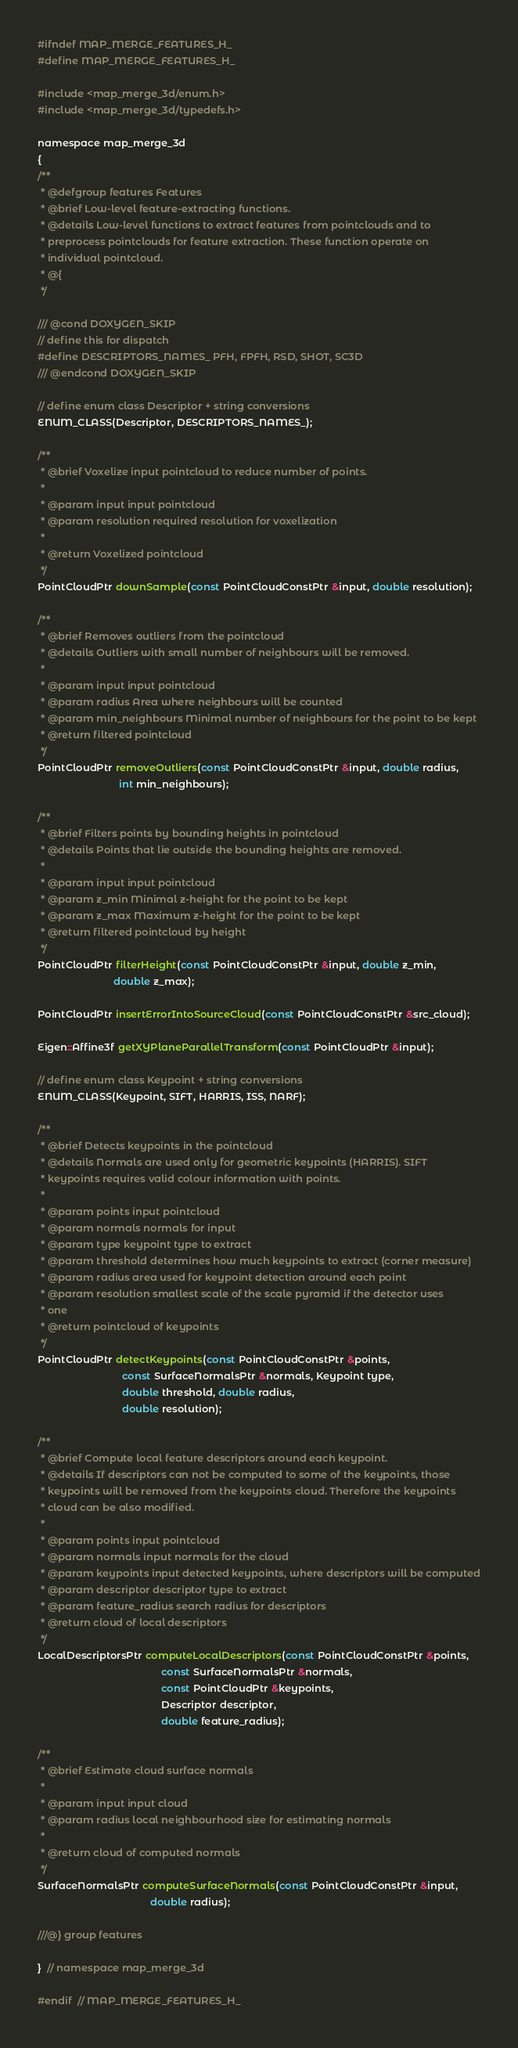<code> <loc_0><loc_0><loc_500><loc_500><_C_>#ifndef MAP_MERGE_FEATURES_H_
#define MAP_MERGE_FEATURES_H_

#include <map_merge_3d/enum.h>
#include <map_merge_3d/typedefs.h>

namespace map_merge_3d
{
/**
 * @defgroup features Features
 * @brief Low-level feature-extracting functions.
 * @details Low-level functions to extract features from pointclouds and to
 * preprocess pointclouds for feature extraction. These function operate on
 * individual pointcloud.
 * @{
 */

/// @cond DOXYGEN_SKIP
// define this for dispatch
#define DESCRIPTORS_NAMES_ PFH, FPFH, RSD, SHOT, SC3D
/// @endcond DOXYGEN_SKIP

// define enum class Descriptor + string conversions
ENUM_CLASS(Descriptor, DESCRIPTORS_NAMES_);

/**
 * @brief Voxelize input pointcloud to reduce number of points.
 *
 * @param input input pointcloud
 * @param resolution required resolution for voxelization
 *
 * @return Voxelized pointcloud
 */
PointCloudPtr downSample(const PointCloudConstPtr &input, double resolution);

/**
 * @brief Removes outliers from the pointcloud
 * @details Outliers with small number of neighbours will be removed.
 *
 * @param input input pointcloud
 * @param radius Area where neighbours will be counted
 * @param min_neighbours Minimal number of neighbours for the point to be kept
 * @return filtered pointcloud
 */
PointCloudPtr removeOutliers(const PointCloudConstPtr &input, double radius,
                             int min_neighbours);

/**
 * @brief Filters points by bounding heights in pointcloud
 * @details Points that lie outside the bounding heights are removed.
 *
 * @param input input pointcloud
 * @param z_min Minimal z-height for the point to be kept
 * @param z_max Maximum z-height for the point to be kept
 * @return filtered pointcloud by height
 */
PointCloudPtr filterHeight(const PointCloudConstPtr &input, double z_min,
                           double z_max);

PointCloudPtr insertErrorIntoSourceCloud(const PointCloudConstPtr &src_cloud);

Eigen::Affine3f getXYPlaneParallelTransform(const PointCloudPtr &input);

// define enum class Keypoint + string conversions
ENUM_CLASS(Keypoint, SIFT, HARRIS, ISS, NARF);

/**
 * @brief Detects keypoints in the pointcloud
 * @details Normals are used only for geometric keypoints (HARRIS). SIFT
 * keypoints requires valid colour information with points.
 *
 * @param points input pointcloud
 * @param normals normals for input
 * @param type keypoint type to extract
 * @param threshold determines how much keypoints to extract (corner measure)
 * @param radius area used for keypoint detection around each point
 * @param resolution smallest scale of the scale pyramid if the detector uses
 * one
 * @return pointcloud of keypoints
 */
PointCloudPtr detectKeypoints(const PointCloudConstPtr &points,
                              const SurfaceNormalsPtr &normals, Keypoint type,
                              double threshold, double radius,
                              double resolution);

/**
 * @brief Compute local feature descriptors around each keypoint.
 * @details If descriptors can not be computed to some of the keypoints, those
 * keypoints will be removed from the keypoints cloud. Therefore the keypoints
 * cloud can be also modified.
 *
 * @param points input pointcloud
 * @param normals input normals for the cloud
 * @param keypoints input detected keypoints, where descriptors will be computed
 * @param descriptor descriptor type to extract
 * @param feature_radius search radius for descriptors
 * @return cloud of local descriptors
 */
LocalDescriptorsPtr computeLocalDescriptors(const PointCloudConstPtr &points,
                                            const SurfaceNormalsPtr &normals,
                                            const PointCloudPtr &keypoints,
                                            Descriptor descriptor,
                                            double feature_radius);

/**
 * @brief Estimate cloud surface normals
 *
 * @param input input cloud
 * @param radius local neighbourhood size for estimating normals
 *
 * @return cloud of computed normals
 */
SurfaceNormalsPtr computeSurfaceNormals(const PointCloudConstPtr &input,
                                        double radius);

///@} group features

}  // namespace map_merge_3d

#endif  // MAP_MERGE_FEATURES_H_
</code> 